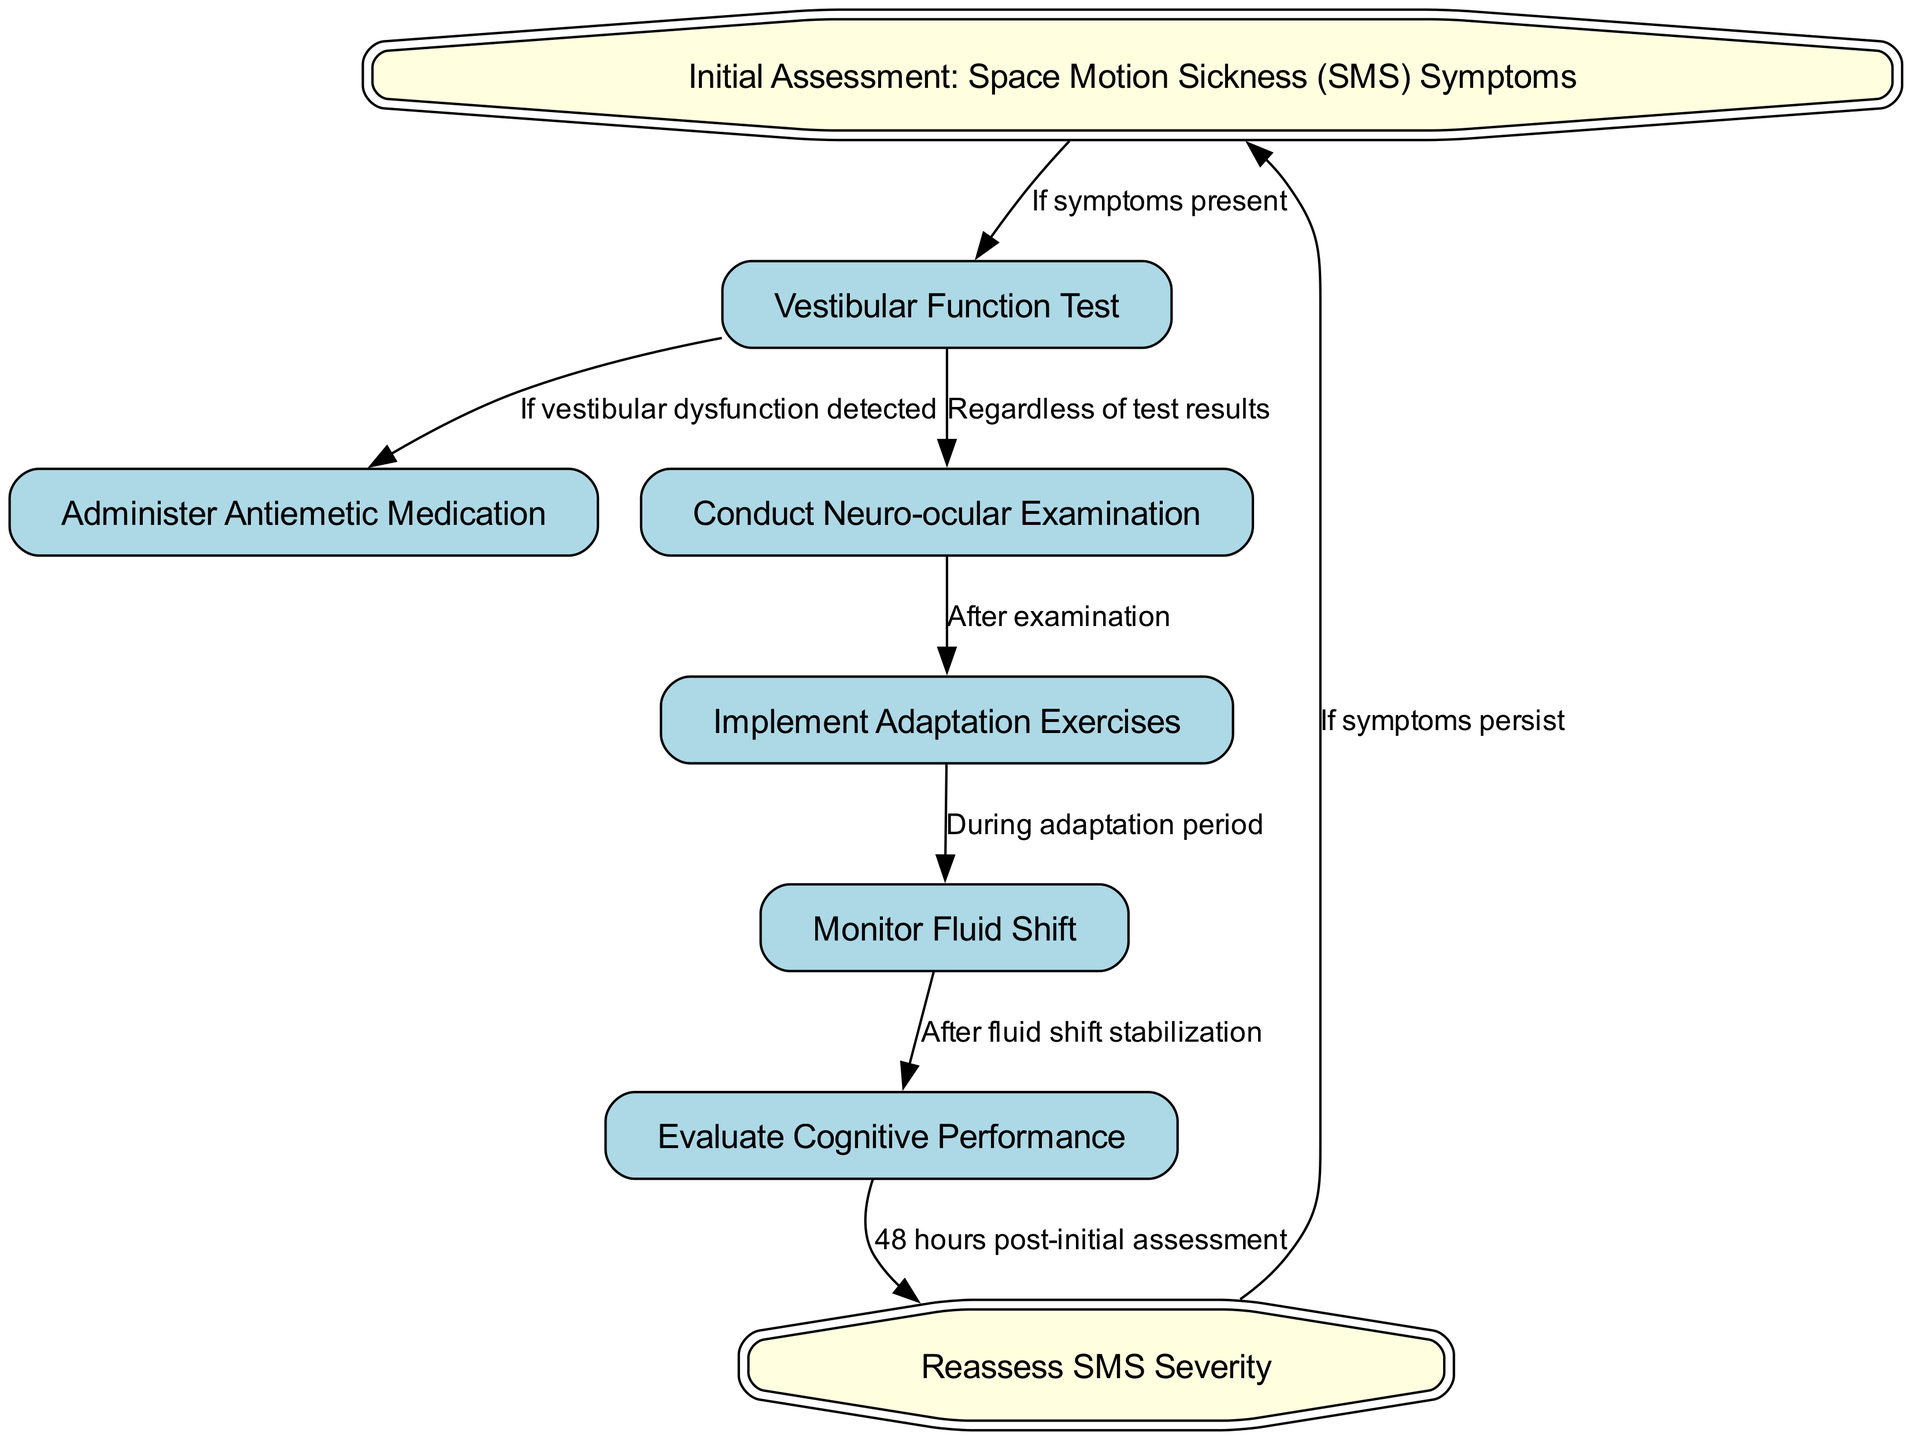What is the first step in the clinical pathway? The first step is represented by the node with id "1", which states "Initial Assessment: Space Motion Sickness (SMS) Symptoms". This is the starting point in the process before any further actions are taken.
Answer: Initial Assessment: Space Motion Sickness (SMS) Symptoms How many nodes are present in the diagram? By counting the nodes listed in the "nodes" section, there are a total of eight distinct elements represented visually in the diagram.
Answer: Eight What action follows if vestibular dysfunction is detected? If vestibular dysfunction is detected from the vestibular function test (node 2), the protocol specifies that the action to take is to "Administer Antiemetic Medication" (node 3).
Answer: Administer Antiemetic Medication After the neuro-ocular examination, which action is implemented? After conducting the "Neuro-ocular Examination" (node 4), the pathway specifies that "Implement Adaptation Exercises" (node 5) will follow as the next step.
Answer: Implement Adaptation Exercises What is the purpose of monitoring fluid shift? Monitoring fluid shift occurs during the adaptation period (node 5) and it helps to assess the physiological changes associated with adaptation, which will lead to the evaluation of cognitive performance.
Answer: Assess physiological changes If symptoms persist after reassessing SMS severity, what is the next step? According to the diagram, if symptoms persist after the action of "Reassess SMS Severity" (node 8), the next step is to return to the "Initial Assessment: Space Motion Sickness (SMS) Symptoms" (node 1).
Answer: Initial Assessment: Space Motion Sickness (SMS) Symptoms How long after the initial assessment should cognitive performance be evaluated? The cognitive performance is evaluated "48 hours post-initial assessment" as indicated in the flow from node 7 to node 8.
Answer: 48 hours What is the relationship between vestibular function testing and neuro-ocular examination? The relationship is described in the diagram where the vestibular function test (node 2) leads to both the "Administer Antiemetic Medication" (node 3) if dysfunction is found and directly to "Conduct Neuro-ocular Examination" (node 4), regardless of results.
Answer: Leads to both How many edges connect the nodes in the diagram? By counting the relationships established in the "edges" section, there are a total of seven connections guiding the flow from one step to another in the clinical pathway.
Answer: Seven 